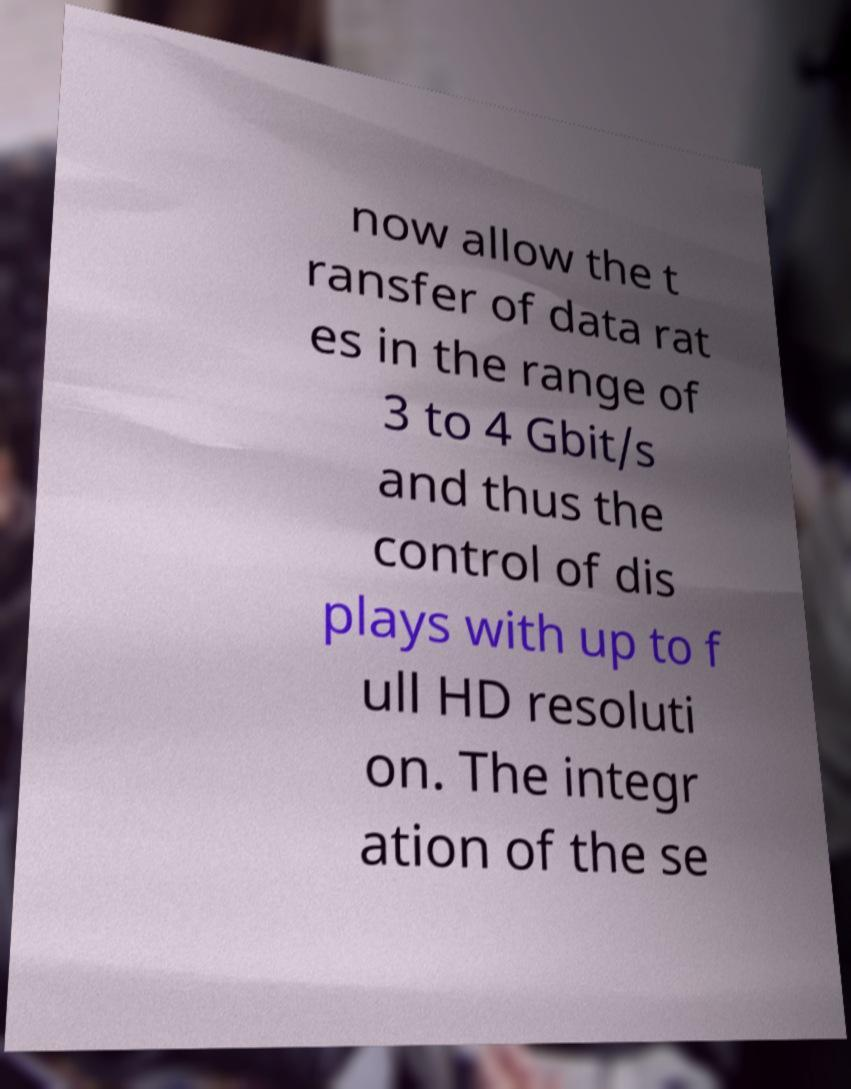Can you accurately transcribe the text from the provided image for me? now allow the t ransfer of data rat es in the range of 3 to 4 Gbit/s and thus the control of dis plays with up to f ull HD resoluti on. The integr ation of the se 